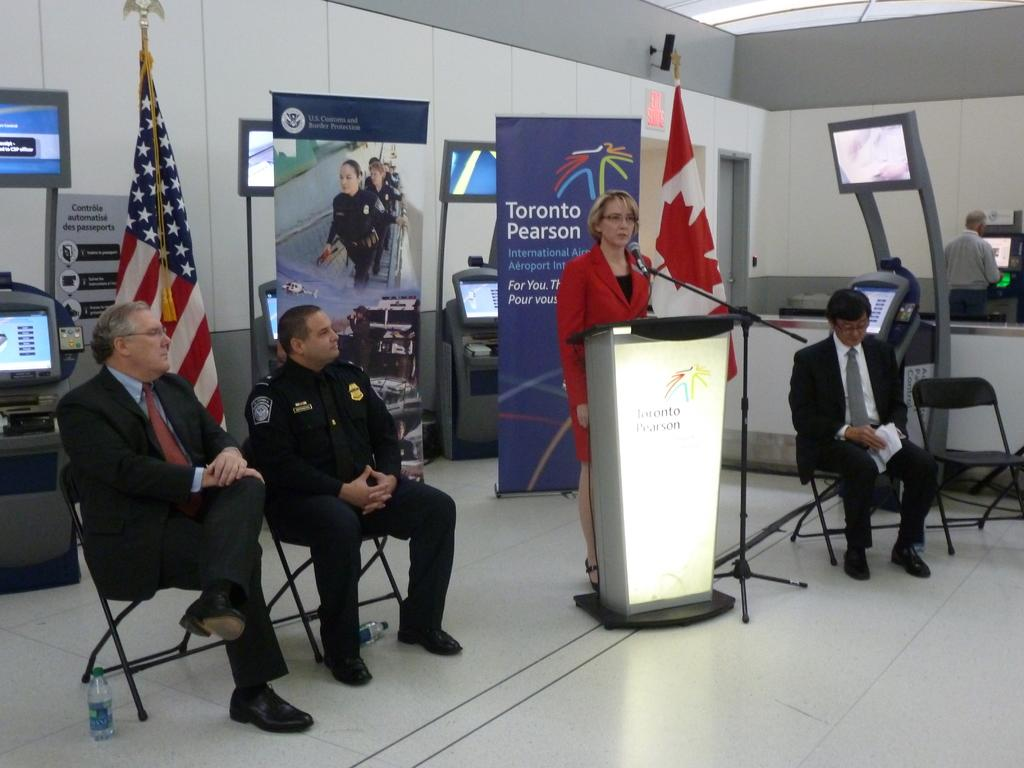Provide a one-sentence caption for the provided image. A woman stands at a podium in front of a sign that says Toronto Pearson. 